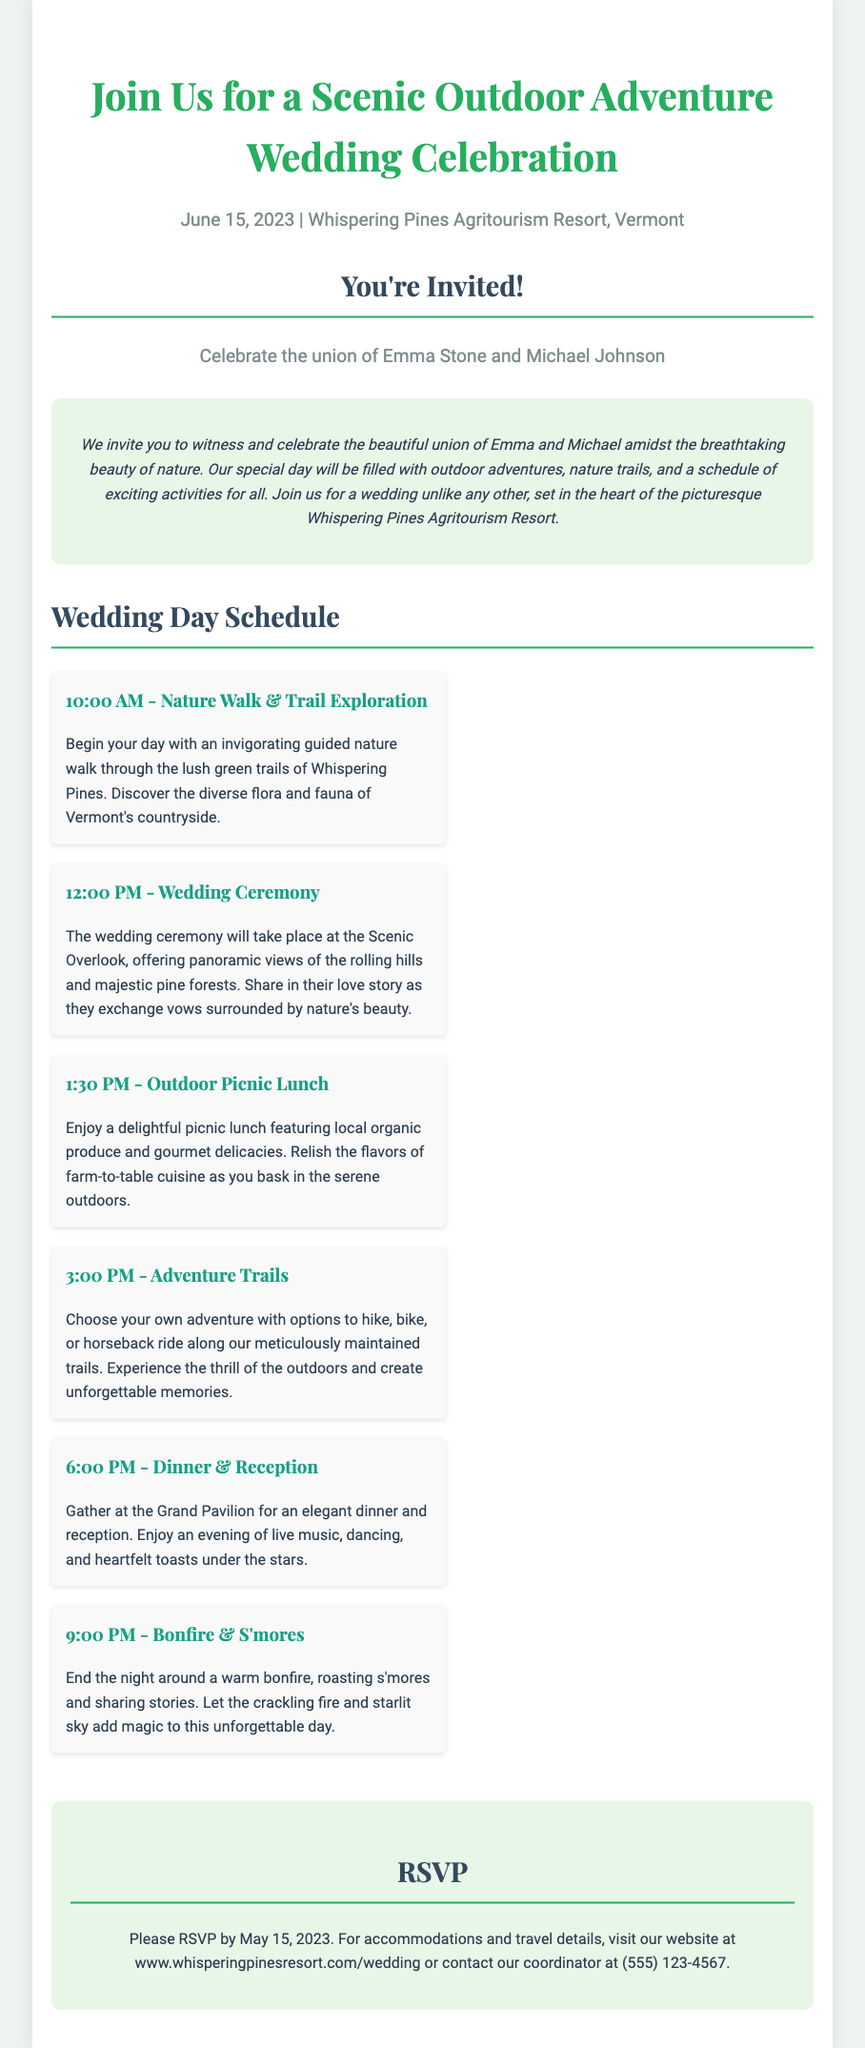What is the date of the wedding? The wedding date is specifically stated in the invitation as "June 15, 2023."
Answer: June 15, 2023 What is the name of the bride? The invitation mentions the bride's full name, Emma Stone.
Answer: Emma Stone Where is the wedding taking place? The location of the wedding is mentioned clearly as "Whispering Pines Agritourism Resort, Vermont."
Answer: Whispering Pines Agritourism Resort, Vermont What time does the wedding ceremony start? The document specifies that the wedding ceremony starts at "12:00 PM."
Answer: 12:00 PM What activity is scheduled at 3:00 PM? The document states that an activity titled "Adventure Trails" is scheduled at this time.
Answer: Adventure Trails What is the last activity outlined in the schedule? The final activity listed in the schedule is "Bonfire & S'mores" occurring at the end of the day.
Answer: Bonfire & S'mores When is the RSVP deadline? The RSVP deadline is explicitly mentioned in the invitation as "May 15, 2023."
Answer: May 15, 2023 What type of cuisine will be served during the lunch? The lunch will feature "local organic produce and gourmet delicacies," which is mentioned in the document.
Answer: local organic produce and gourmet delicacies Who should be contacted for accommodation details? The invitation states that the contact number for the coordinator is provided for accommodation inquiries.
Answer: (555) 123-4567 